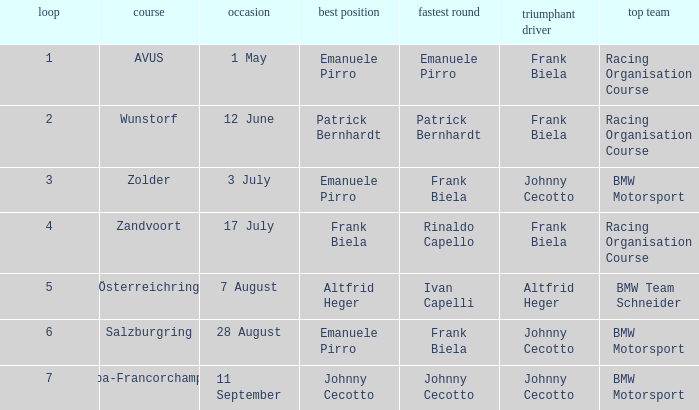Who achieved pole position in the seventh round? Johnny Cecotto. 